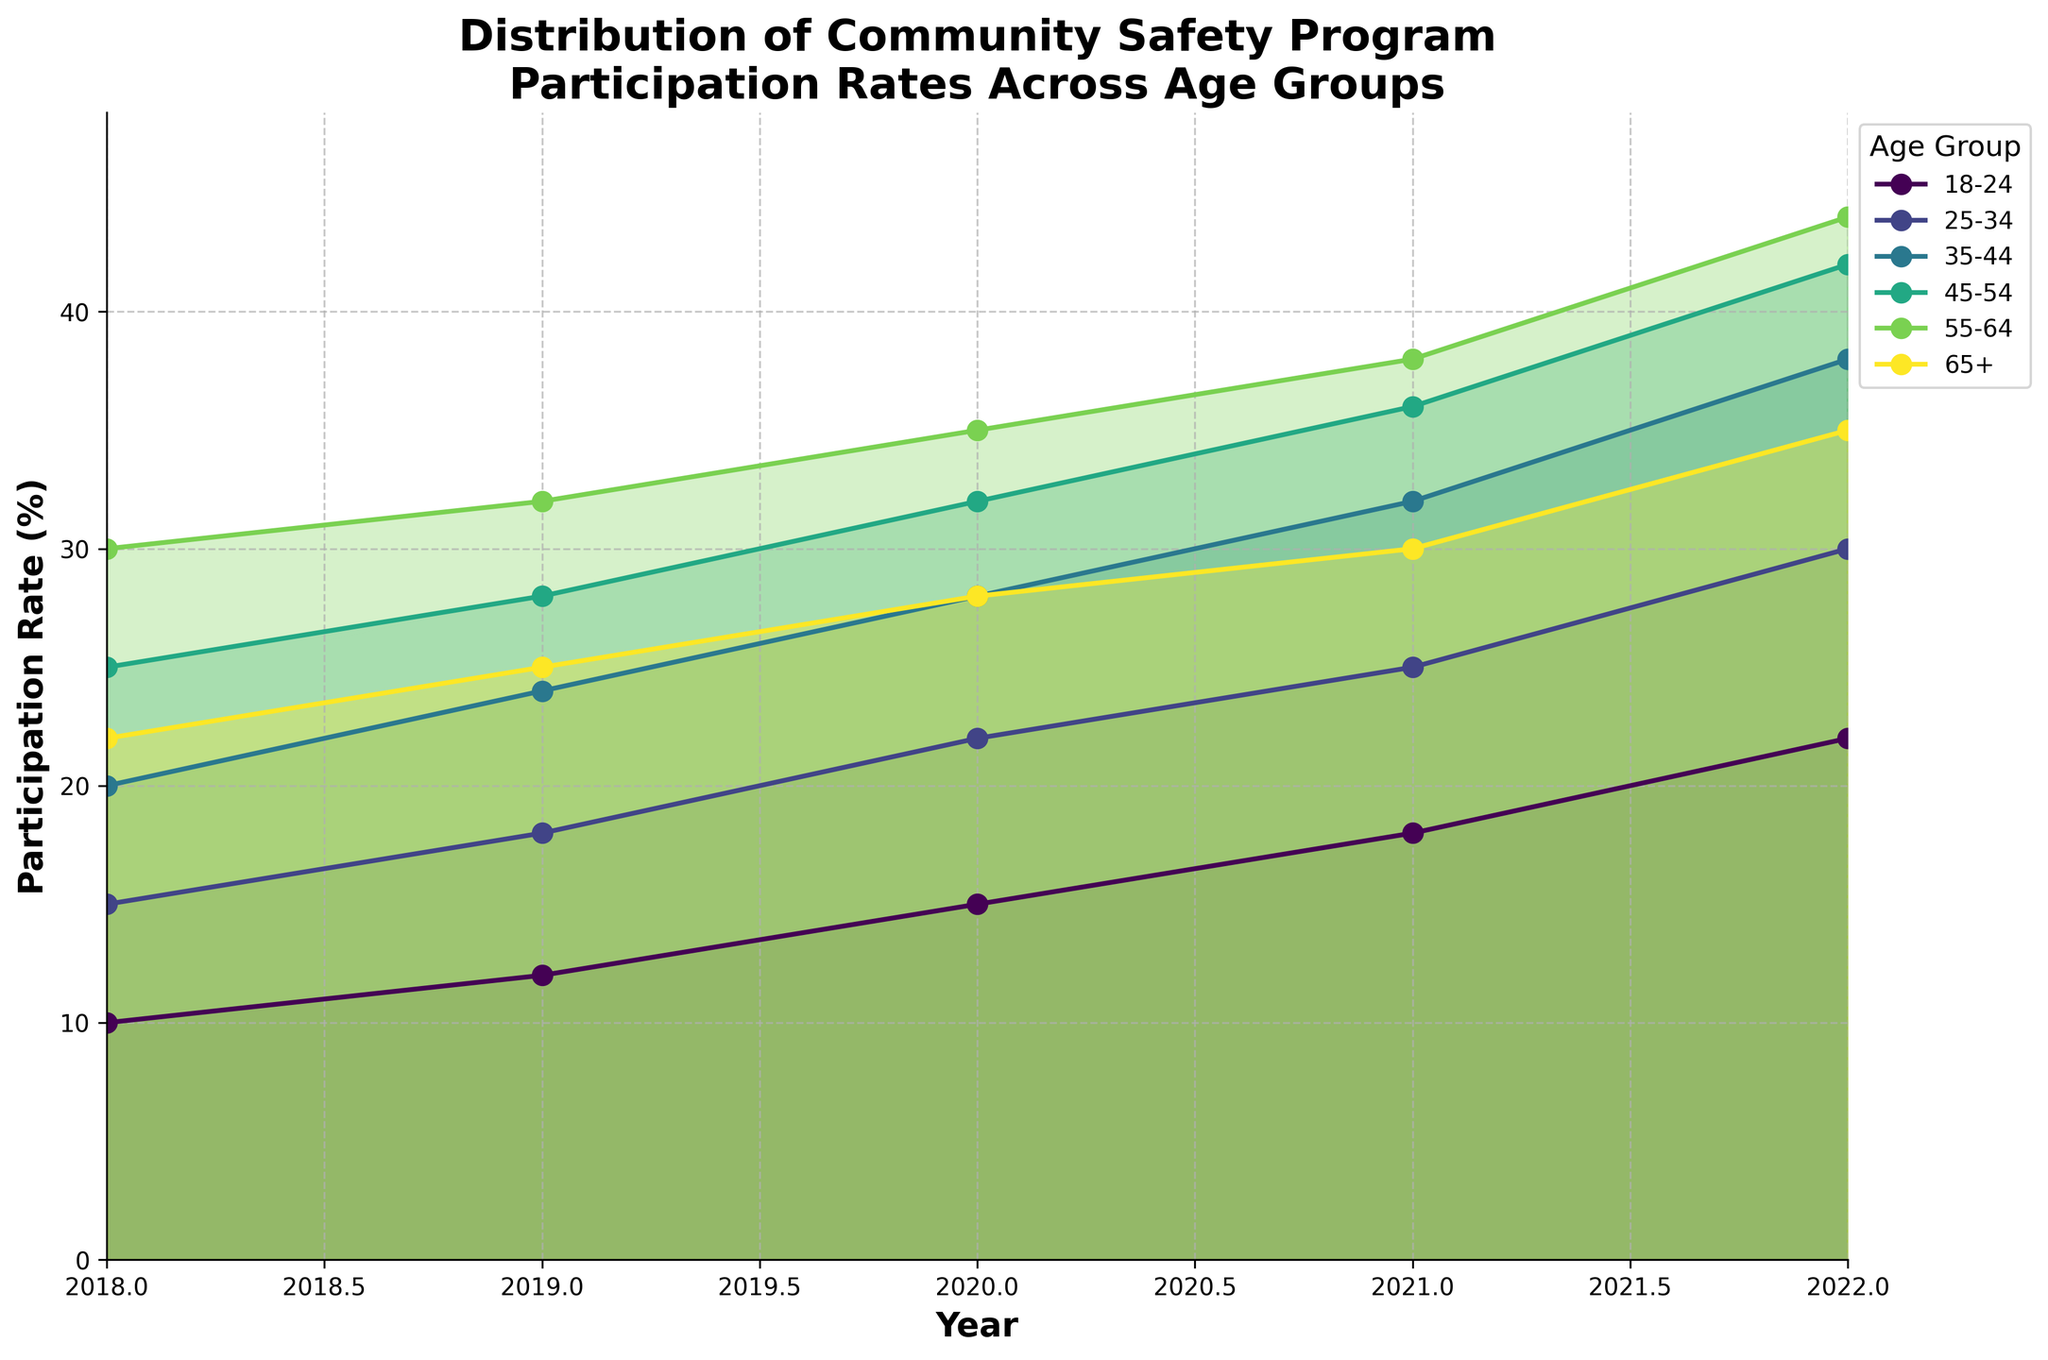What is the title of the chart? The title of the chart is prominently displayed at the top and it reads: "Distribution of Community Safety Program Participation Rates Across Age Groups".
Answer: "Distribution of Community Safety Program Participation Rates Across Age Groups" What does the x-axis represent? The x-axis is labeled "Year", indicating that it represents the years over which the participation rates are measured, specifically 2018 to 2022.
Answer: Year Which age group had the highest participation rate in 2022? By looking at the line plot for each age group, the 55-64 age group had the highest participation rate in 2022, reaching 44%.
Answer: 55-64 Which age group shows the most significant increase in participation rate from 2018 to 2022? By identifying the steepest slope from 2018 to 2022, the 18-24 age group shows the most significant increase, starting from 10% and rising to 22% (an increase of 12 percentage points).
Answer: 18-24 Which two age groups had a participation rate of 28% in 2020? By examining the y-axis values for 2020, the 35-44 and 45-54 age groups both had a participation rate of 28%.
Answer: 35-44 and 45-54 What is the average participation rate for the 25-34 age group across all years shown? Adding the values for the 25-34 age group for 2018 (15), 2019 (18), 2020 (22), 2021 (25), and 2022 (30), then dividing by the number of years (5), results in (15+18+22+25+30)/5 = 22.
Answer: 22 Which age group had the smallest participation rate in 2018? By looking at the values in 2018, the 18-24 age group had the smallest participation rate, at 10%.
Answer: 18-24 How do the participation rates of the 65+ age group compare between 2020 and 2022? In 2020, the 65+ age group's participation rate was 28%, and in 2022, it was 35%, indicating an increase of 7 percentage points. The 2022 rate is greater than the 2020 rate.
Answer: The rate increased from 28% to 35% Which age group shows the least variance in participation rates over the years? By observing the lines for all age groups, the 65+ age group appears to have the least variance, as the difference between the highest (35%) and lowest (22%) values is 13 percentage points.
Answer: 65+ 